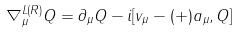<formula> <loc_0><loc_0><loc_500><loc_500>\nabla _ { \mu } ^ { L ( R ) } Q = \partial _ { \mu } Q - i [ v _ { \mu } - ( + ) a _ { \mu } , Q ]</formula> 